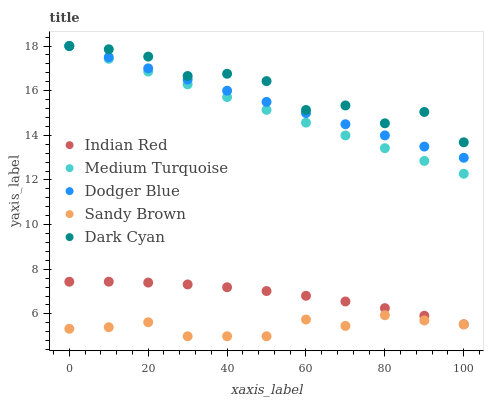Does Sandy Brown have the minimum area under the curve?
Answer yes or no. Yes. Does Dark Cyan have the maximum area under the curve?
Answer yes or no. Yes. Does Dodger Blue have the minimum area under the curve?
Answer yes or no. No. Does Dodger Blue have the maximum area under the curve?
Answer yes or no. No. Is Medium Turquoise the smoothest?
Answer yes or no. Yes. Is Dark Cyan the roughest?
Answer yes or no. Yes. Is Sandy Brown the smoothest?
Answer yes or no. No. Is Sandy Brown the roughest?
Answer yes or no. No. Does Sandy Brown have the lowest value?
Answer yes or no. Yes. Does Dodger Blue have the lowest value?
Answer yes or no. No. Does Medium Turquoise have the highest value?
Answer yes or no. Yes. Does Sandy Brown have the highest value?
Answer yes or no. No. Is Sandy Brown less than Medium Turquoise?
Answer yes or no. Yes. Is Dodger Blue greater than Indian Red?
Answer yes or no. Yes. Does Dodger Blue intersect Dark Cyan?
Answer yes or no. Yes. Is Dodger Blue less than Dark Cyan?
Answer yes or no. No. Is Dodger Blue greater than Dark Cyan?
Answer yes or no. No. Does Sandy Brown intersect Medium Turquoise?
Answer yes or no. No. 